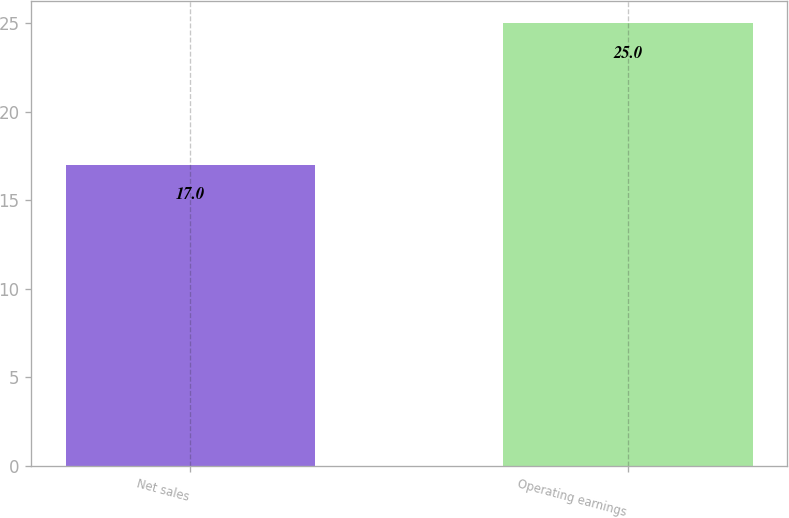Convert chart to OTSL. <chart><loc_0><loc_0><loc_500><loc_500><bar_chart><fcel>Net sales<fcel>Operating earnings<nl><fcel>17<fcel>25<nl></chart> 